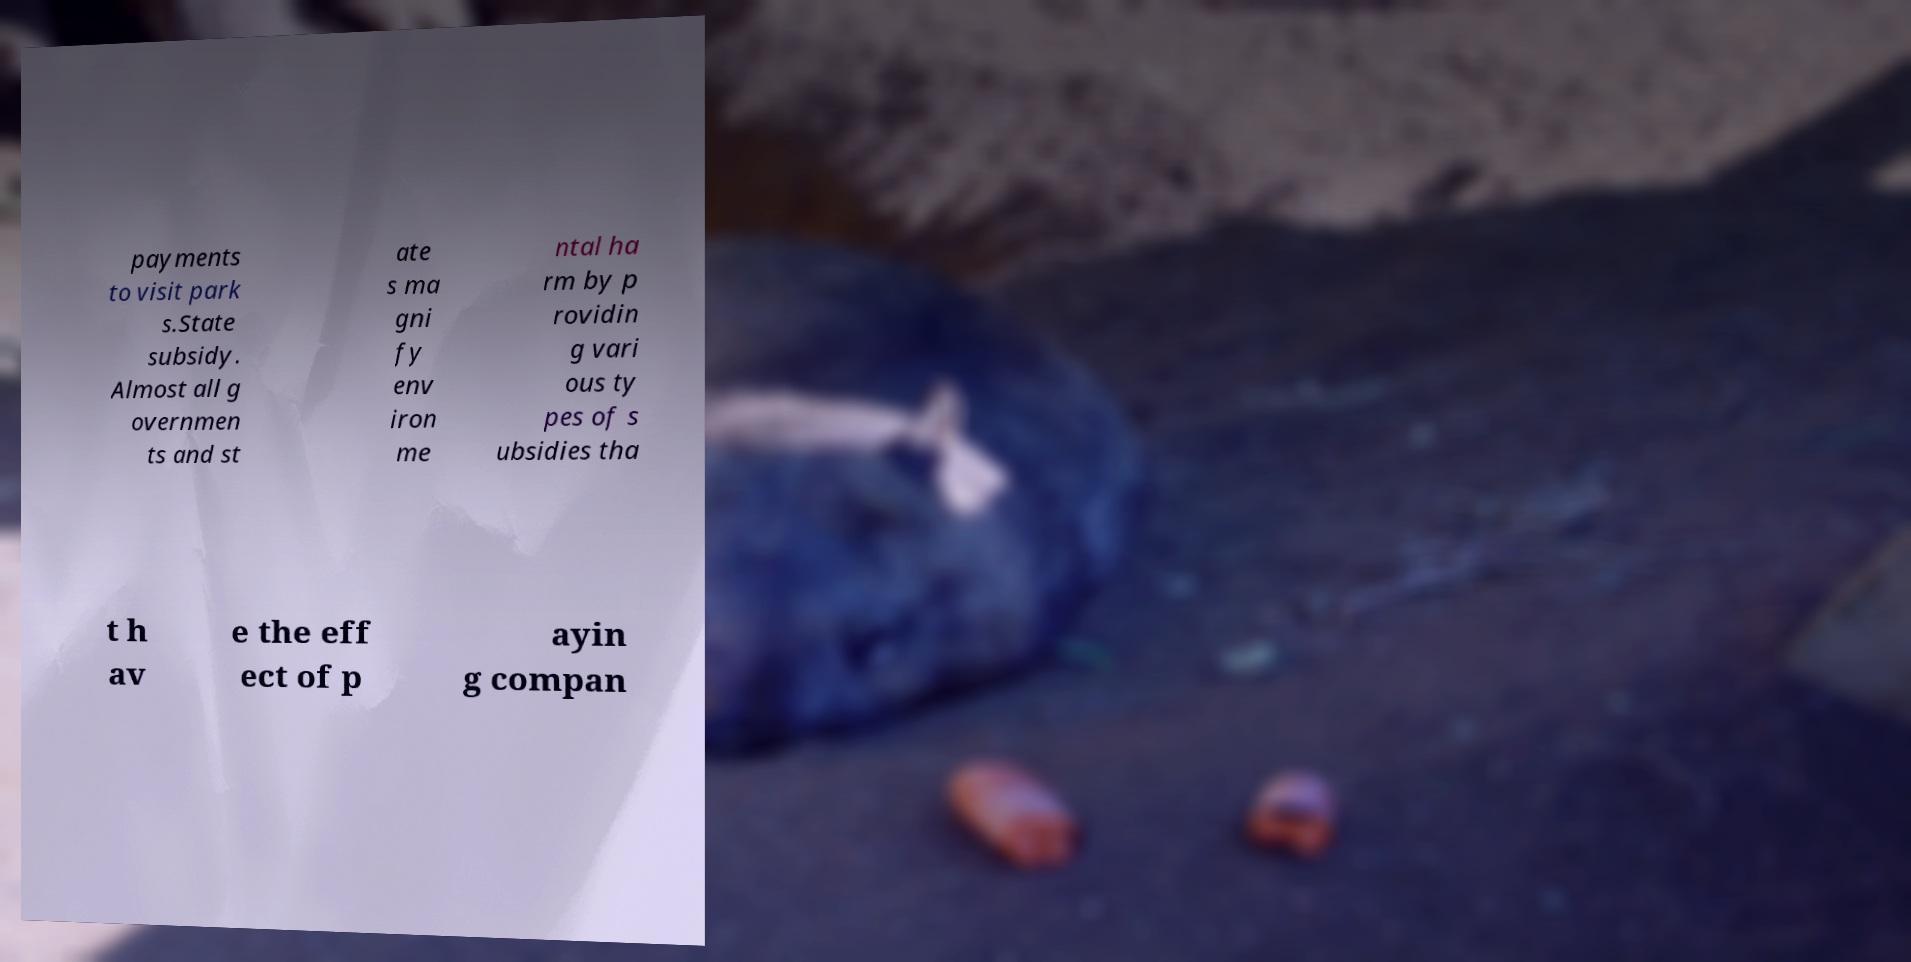Can you accurately transcribe the text from the provided image for me? payments to visit park s.State subsidy. Almost all g overnmen ts and st ate s ma gni fy env iron me ntal ha rm by p rovidin g vari ous ty pes of s ubsidies tha t h av e the eff ect of p ayin g compan 